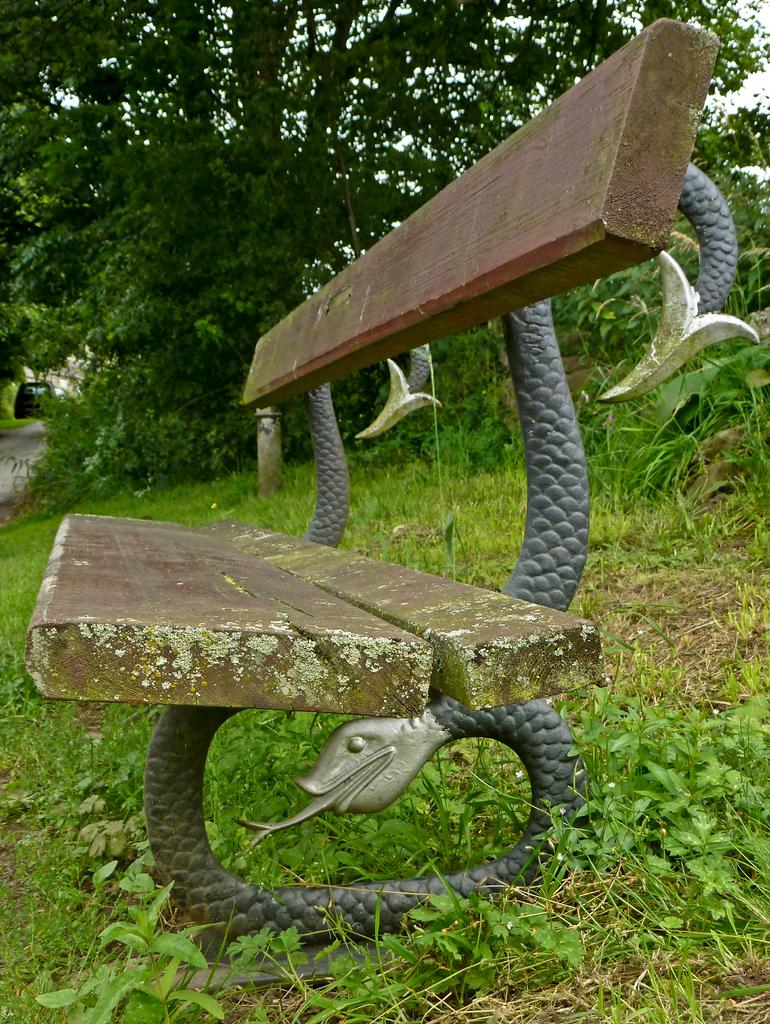What type of seating is visible in the image? There is a bench in the image. What is located on the ground in the image? There is an object on the ground. What type of vegetation can be seen in the image? There is grass, plants, and trees in the image. What part of the natural environment is visible in the image? The sky is visible in the image. What type of popcorn can be seen growing on the trees in the image? There is no popcorn present in the image; it is a natural environment with trees and plants. How does the viewer control the weather in the image? The image is a static representation and does not allow for any control over the weather or any other aspect of the scene. 